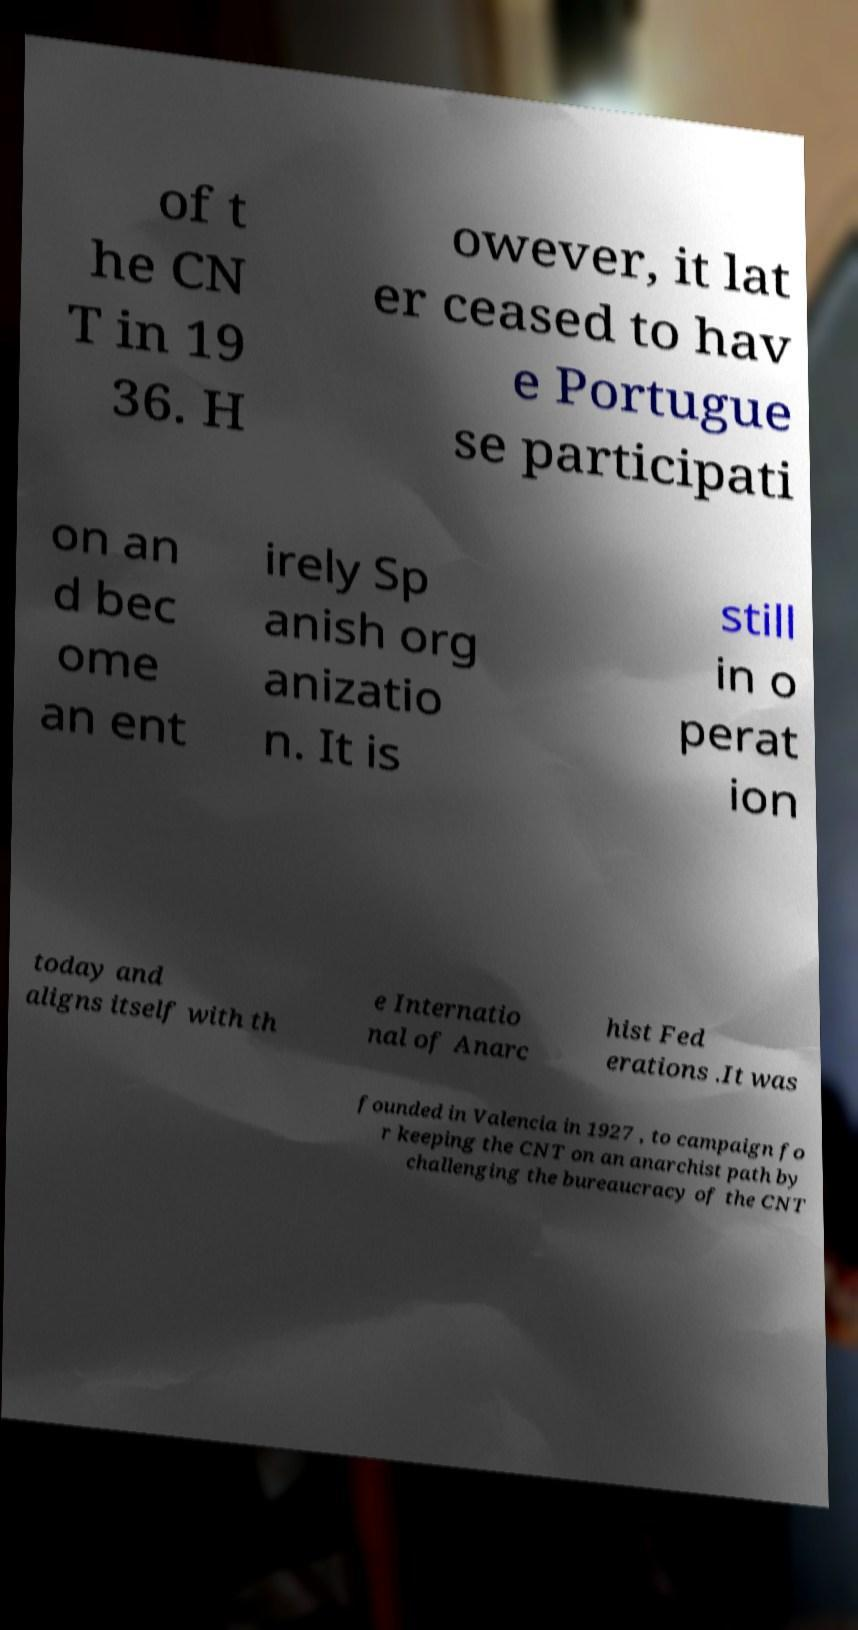Can you read and provide the text displayed in the image?This photo seems to have some interesting text. Can you extract and type it out for me? of t he CN T in 19 36. H owever, it lat er ceased to hav e Portugue se participati on an d bec ome an ent irely Sp anish org anizatio n. It is still in o perat ion today and aligns itself with th e Internatio nal of Anarc hist Fed erations .It was founded in Valencia in 1927 , to campaign fo r keeping the CNT on an anarchist path by challenging the bureaucracy of the CNT 